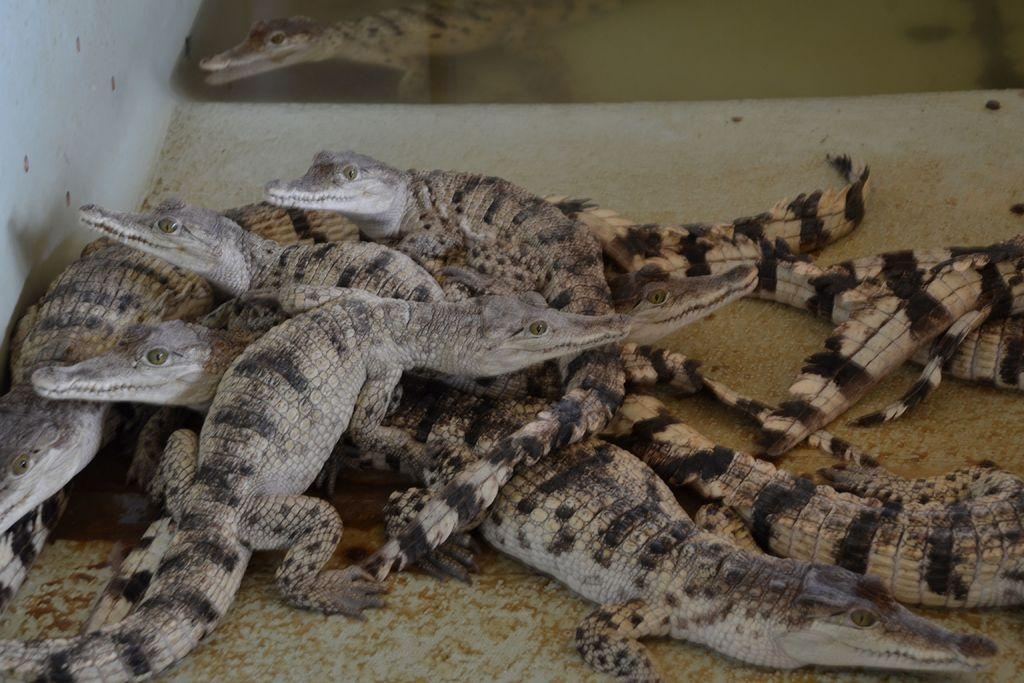What type of animals are present in the image? There are many crocodiles in the image. What is located on the left side of the image? There is a wall on the left side of the image. What type of pest can be seen in the image? There is no pest present in the image; it features many crocodiles. What type of book is visible in the image? There is no book present in the image. What type of battle is taking place in the image? There is no battle present in the image; it features many crocodiles and a wall. 